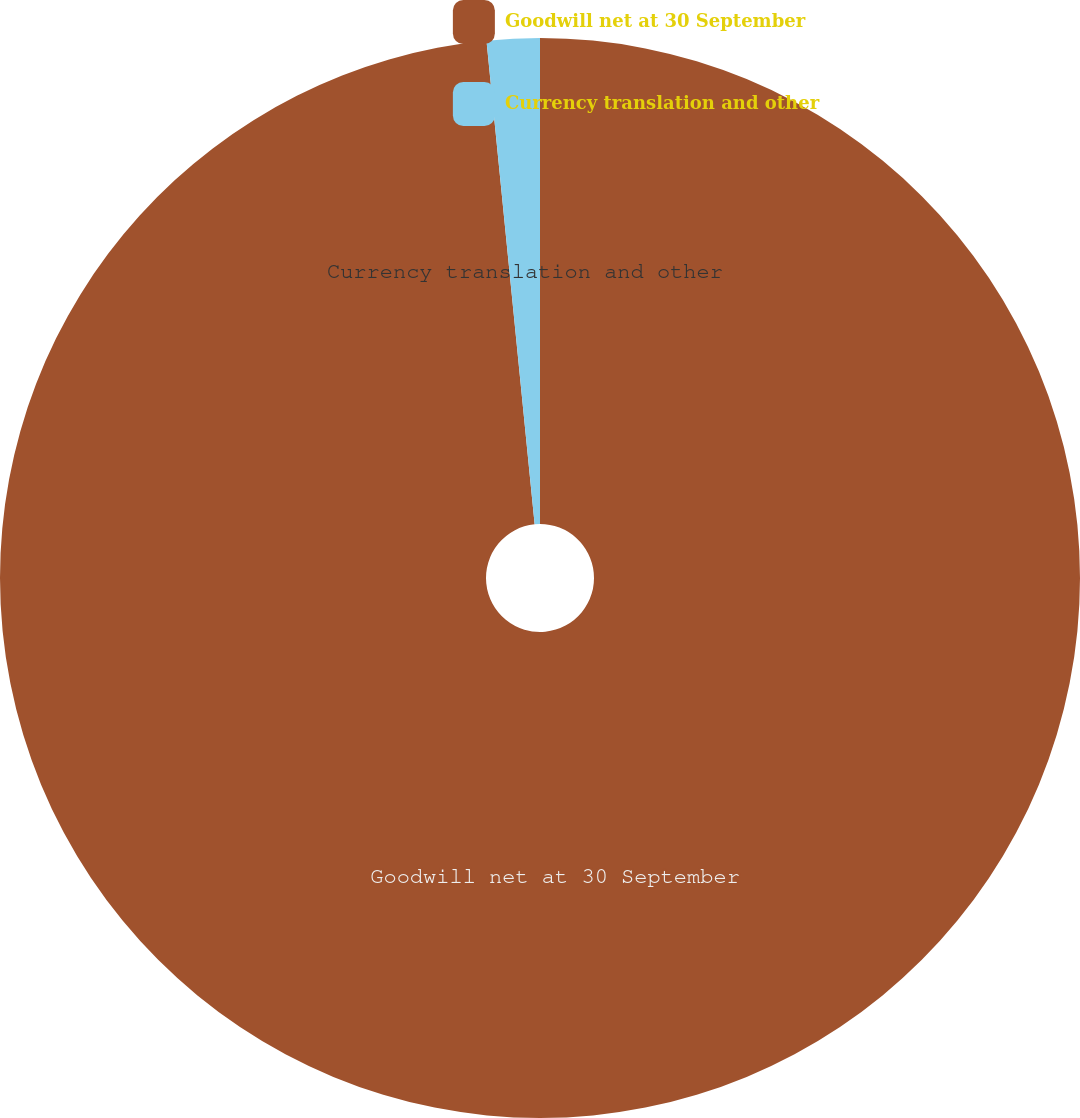Convert chart. <chart><loc_0><loc_0><loc_500><loc_500><pie_chart><fcel>Goodwill net at 30 September<fcel>Currency translation and other<nl><fcel>98.42%<fcel>1.58%<nl></chart> 